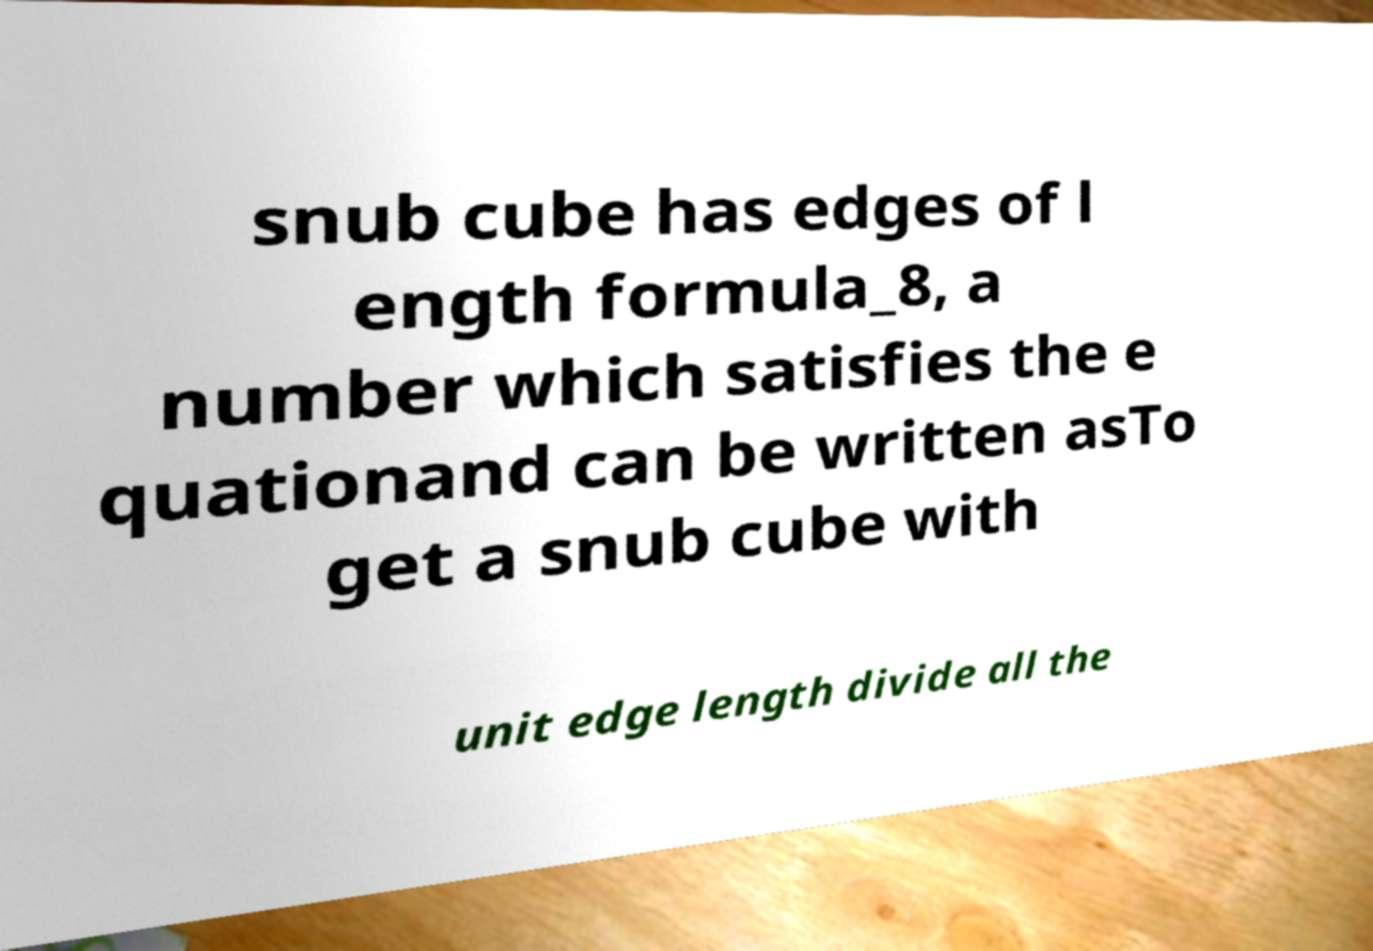There's text embedded in this image that I need extracted. Can you transcribe it verbatim? snub cube has edges of l ength formula_8, a number which satisfies the e quationand can be written asTo get a snub cube with unit edge length divide all the 